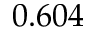Convert formula to latex. <formula><loc_0><loc_0><loc_500><loc_500>0 . 6 0 4</formula> 